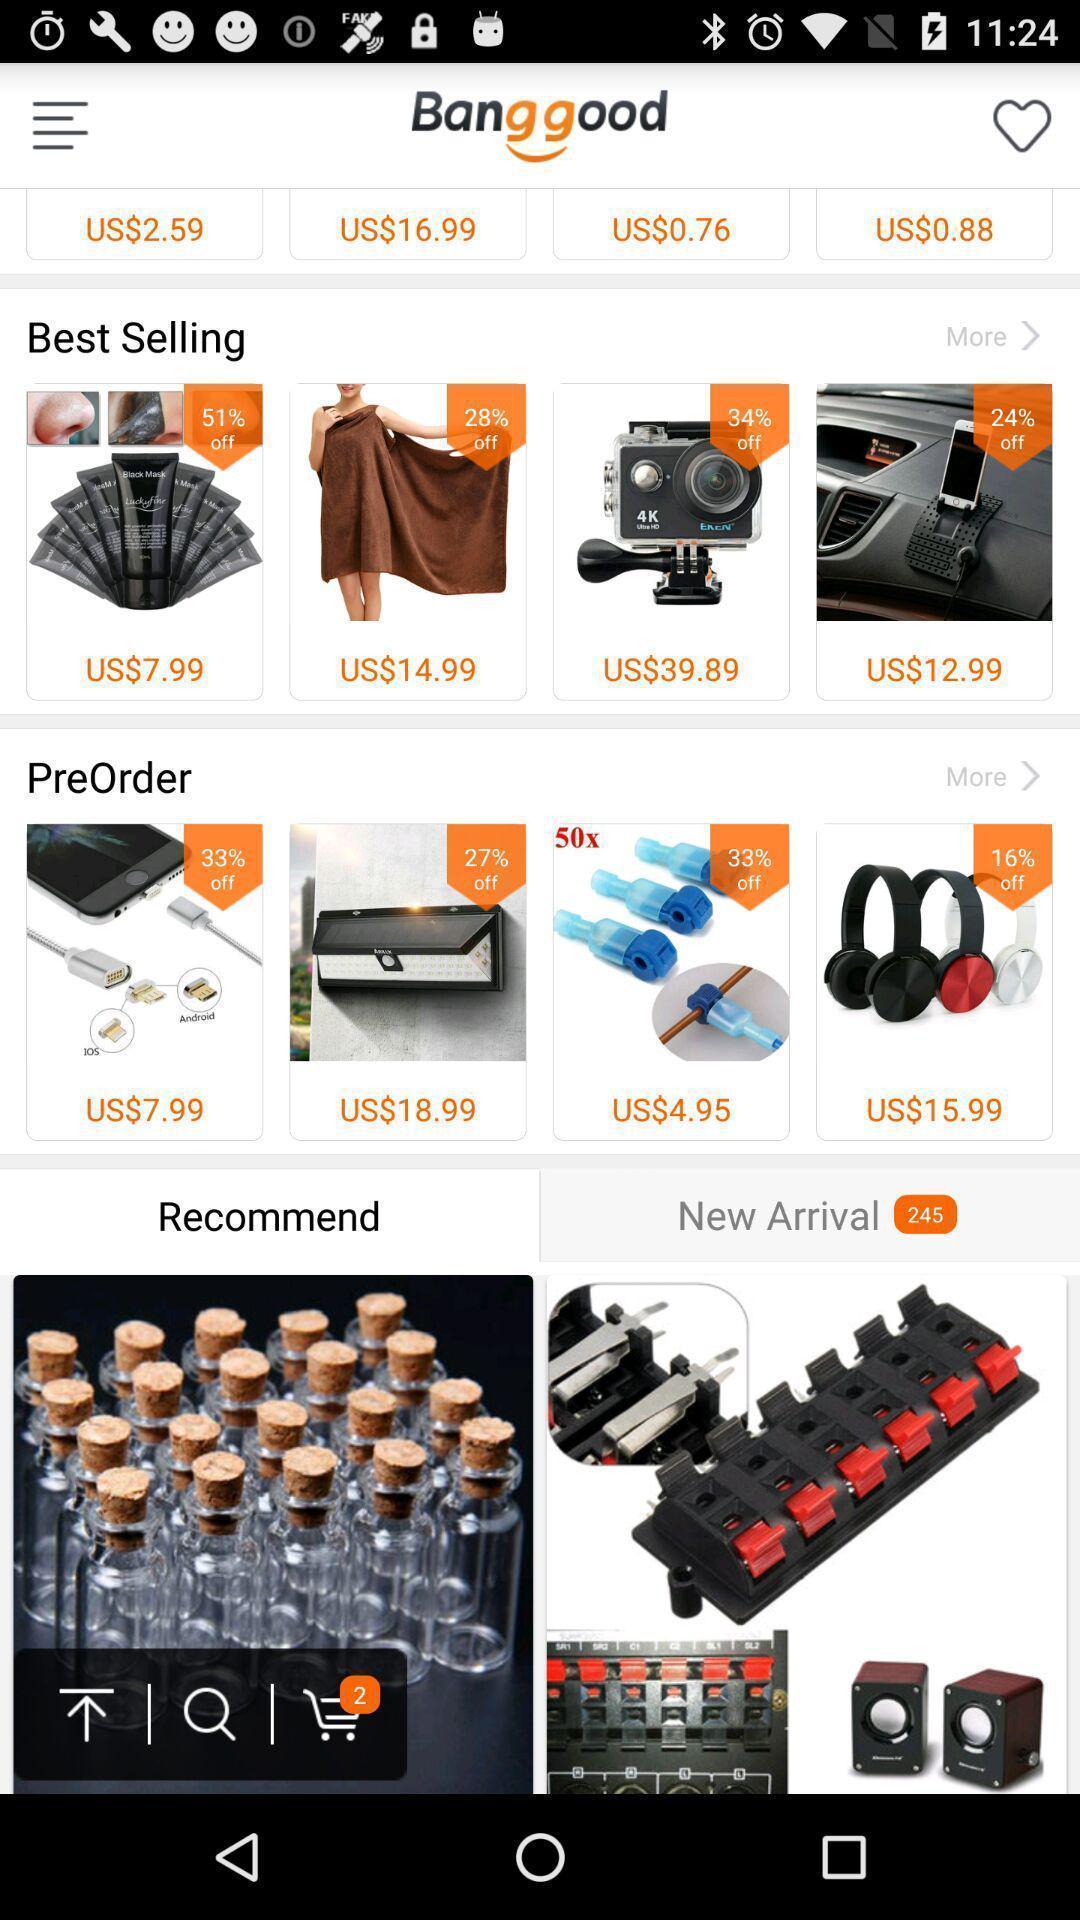What is the overall content of this screenshot? Social app for online shopping. 